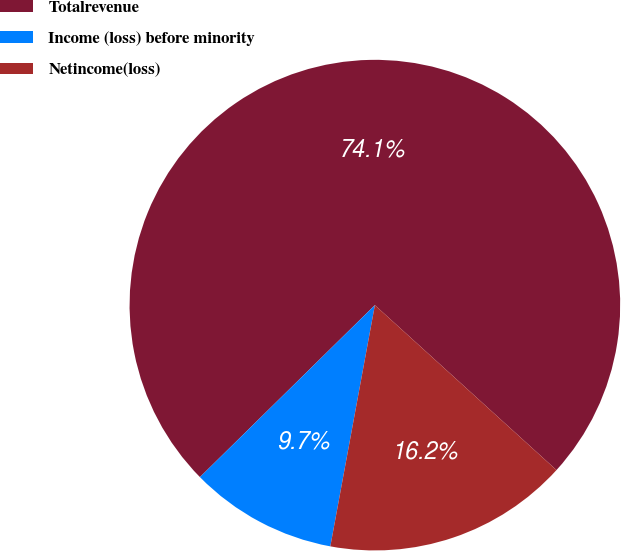<chart> <loc_0><loc_0><loc_500><loc_500><pie_chart><fcel>Totalrevenue<fcel>Income (loss) before minority<fcel>Netincome(loss)<nl><fcel>74.1%<fcel>9.73%<fcel>16.17%<nl></chart> 